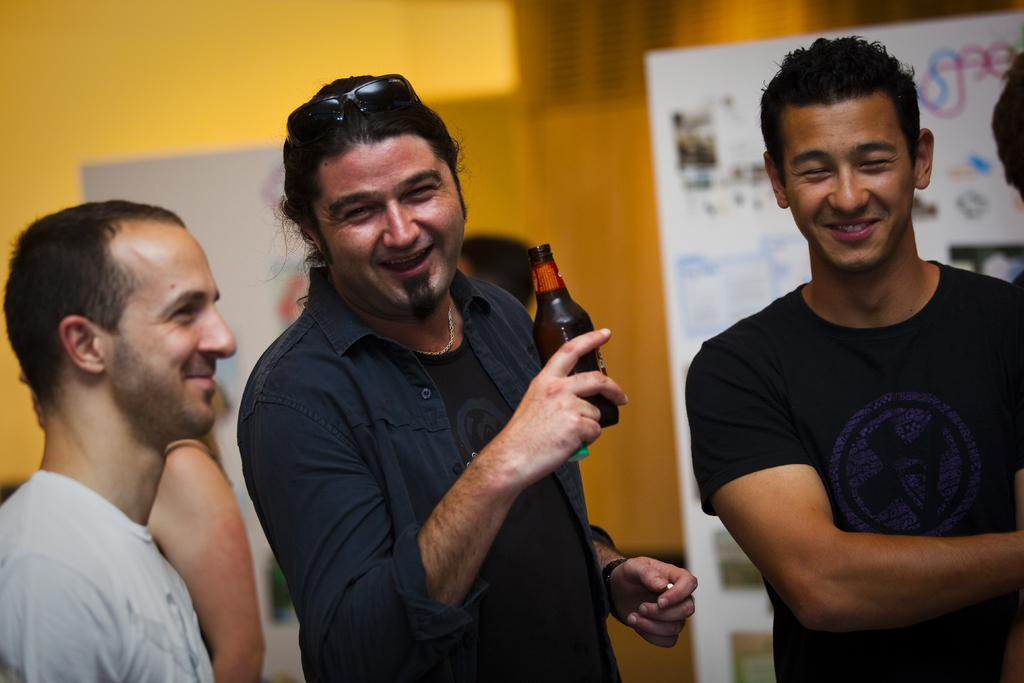How many people are standing in the image? There are three persons standing in the image. Can you describe any specific features of one of the persons? One person is wearing goggles. What is the person wearing goggles holding? The person wearing goggles is holding a bottle. What can be seen in the background of the image? There is a banner and a yellow wall in the background. What type of development is the manager overseeing in the image? There is no indication of a manager or any development in the image. Is there any smoke visible in the image? There is no smoke present in the image. 